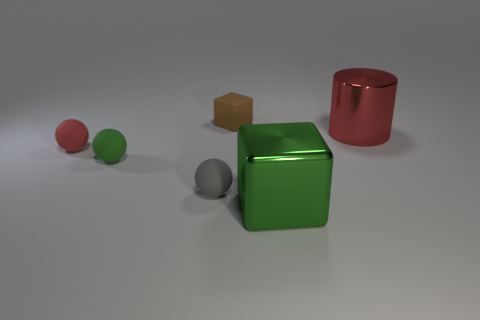What number of brown things are in front of the red sphere?
Your answer should be very brief. 0. There is a cube that is in front of the metallic object that is behind the large block; is there a big metal thing behind it?
Your response must be concise. Yes. How many gray rubber objects have the same size as the brown rubber cube?
Keep it short and to the point. 1. What is the material of the big object that is on the right side of the thing in front of the tiny gray ball?
Offer a terse response. Metal. There is a red thing in front of the metallic thing that is behind the tiny ball that is to the left of the green rubber object; what is its shape?
Give a very brief answer. Sphere. There is a tiny rubber thing that is to the right of the gray matte object; is its shape the same as the metallic thing behind the red rubber object?
Offer a terse response. No. How many other things are made of the same material as the tiny green object?
Offer a very short reply. 3. What is the shape of the large thing that is made of the same material as the large block?
Offer a terse response. Cylinder. Does the gray sphere have the same size as the red metallic object?
Provide a succinct answer. No. How big is the thing that is behind the red metal thing that is on the right side of the small gray matte ball?
Offer a terse response. Small. 